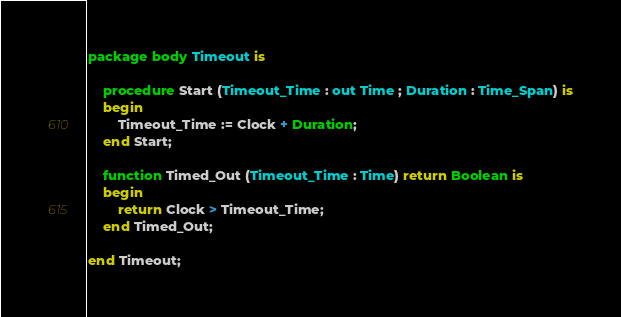Convert code to text. <code><loc_0><loc_0><loc_500><loc_500><_Ada_>package body Timeout is

	procedure Start (Timeout_Time : out Time ; Duration : Time_Span) is
	begin
		Timeout_Time := Clock + Duration;
	end Start;

	function Timed_Out (Timeout_Time : Time) return Boolean is
	begin
		return Clock > Timeout_Time;
	end Timed_Out;

end Timeout;
</code> 